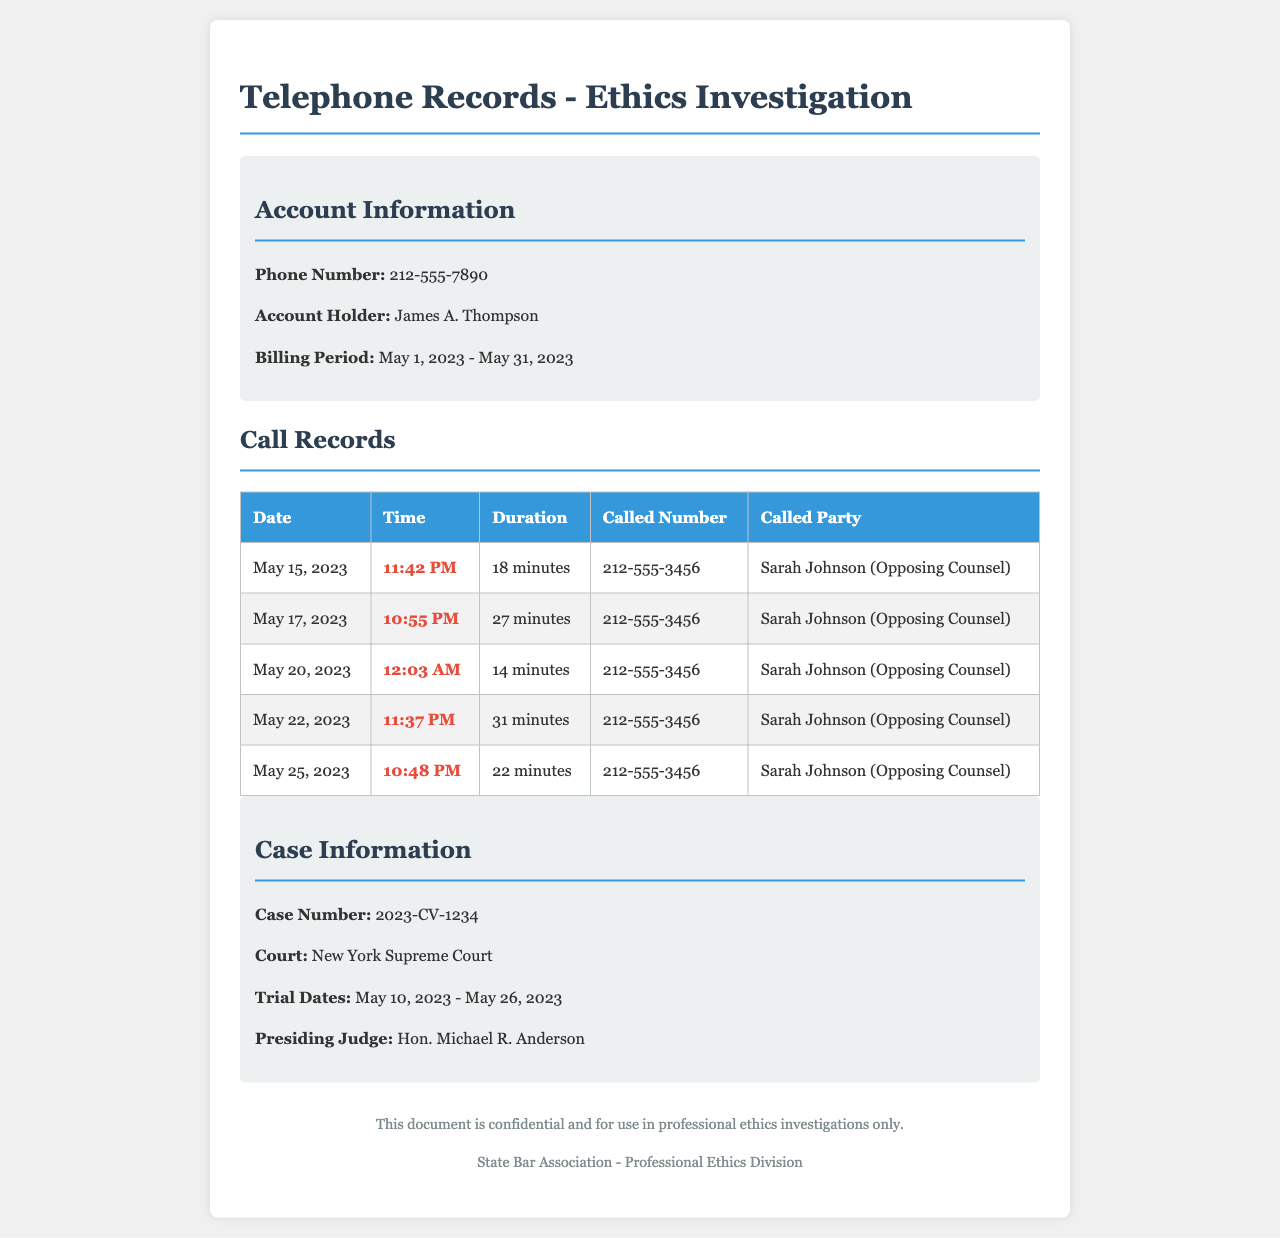What is the phone number associated with the account? The phone number is listed in the account information section of the document.
Answer: 212-555-7890 Who is the account holder? The account holder's name is provided in the header information.
Answer: James A. Thompson What is the initial trial date? The trial dates are specified in the case information section, indicating the first date of the trial.
Answer: May 10, 2023 How many minutes did the longest call to opposing counsel last? The call durations are listed in the call records table; the longest is 31 minutes.
Answer: 31 minutes On what date was the last call made? The call records table indicates the date of the last recorded call.
Answer: May 25, 2023 What is the case number? The case number is included in the case information section of the document.
Answer: 2023-CV-1234 How many late-night calls were made to Sarah Johnson? The table lists the calls, and counting those at night reveals the answer.
Answer: Five Who is listed as the opposing counsel? The called party in each record indicates the name of the opposing counsel.
Answer: Sarah Johnson What time was the earliest call to opposing counsel? The earliest time can be determined by checking the times of the calls in the records.
Answer: 10:48 PM 